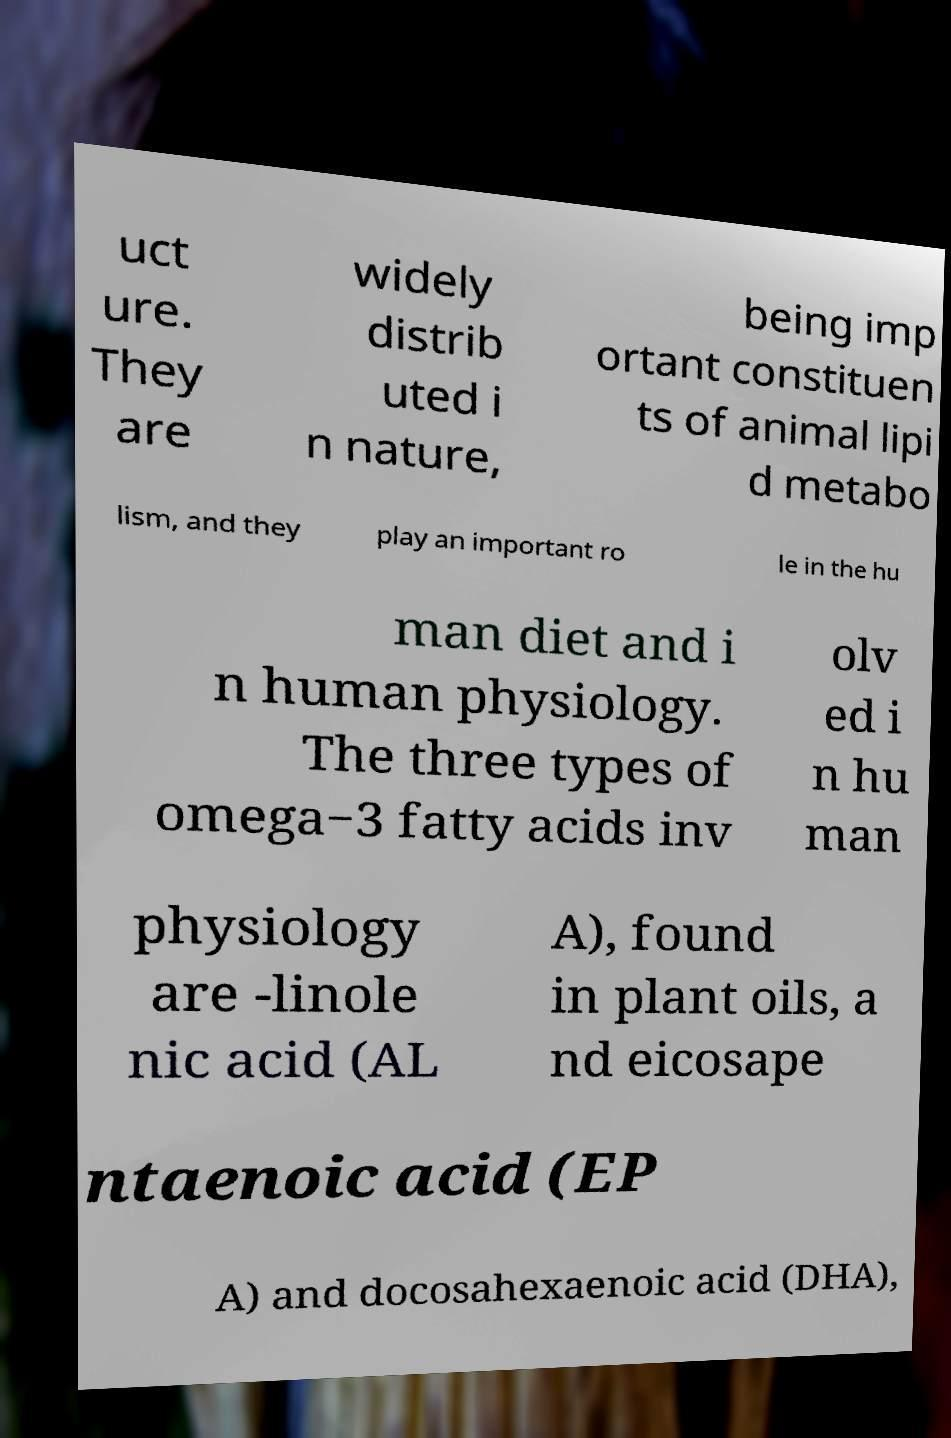Could you extract and type out the text from this image? uct ure. They are widely distrib uted i n nature, being imp ortant constituen ts of animal lipi d metabo lism, and they play an important ro le in the hu man diet and i n human physiology. The three types of omega−3 fatty acids inv olv ed i n hu man physiology are -linole nic acid (AL A), found in plant oils, a nd eicosape ntaenoic acid (EP A) and docosahexaenoic acid (DHA), 